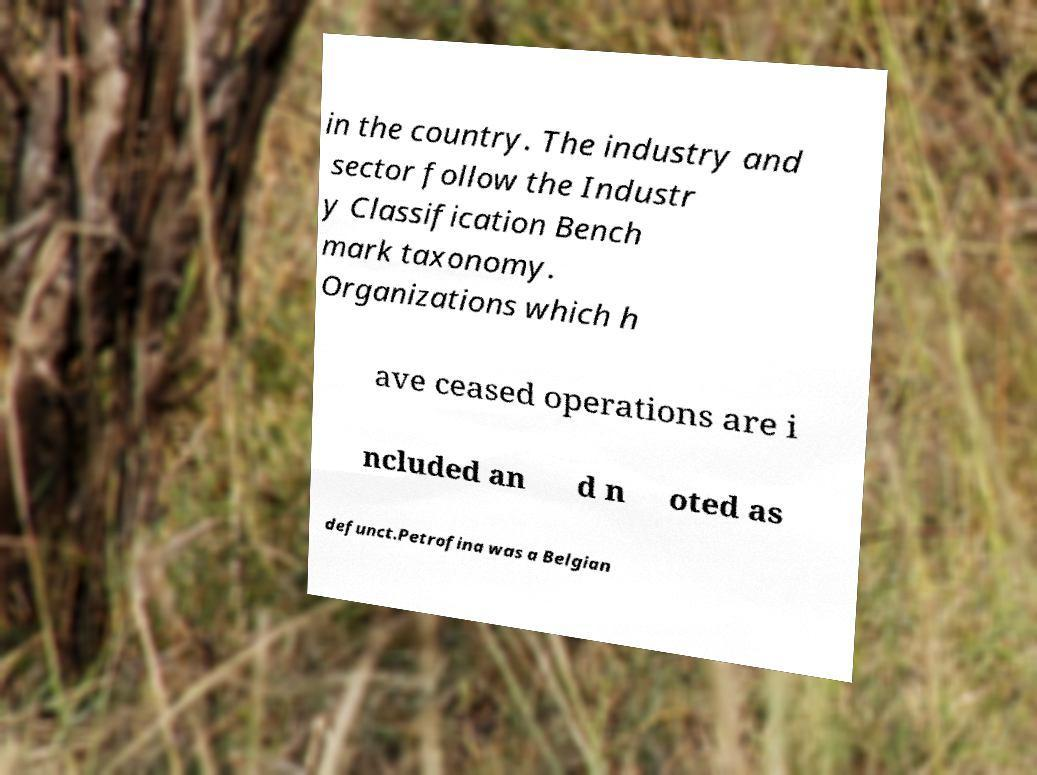Can you accurately transcribe the text from the provided image for me? in the country. The industry and sector follow the Industr y Classification Bench mark taxonomy. Organizations which h ave ceased operations are i ncluded an d n oted as defunct.Petrofina was a Belgian 